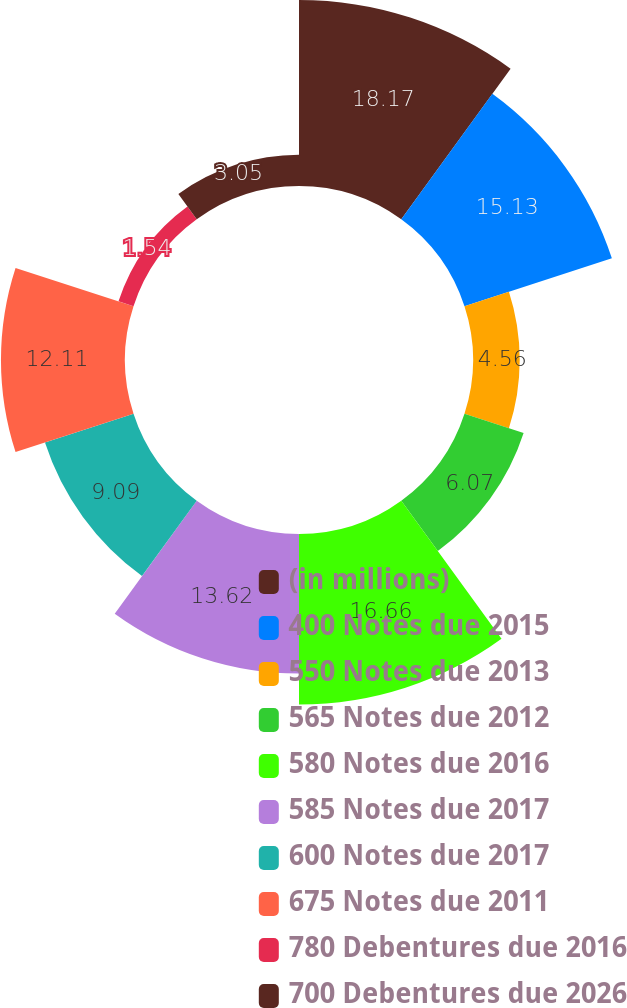Convert chart. <chart><loc_0><loc_0><loc_500><loc_500><pie_chart><fcel>(in millions)<fcel>400 Notes due 2015<fcel>550 Notes due 2013<fcel>565 Notes due 2012<fcel>580 Notes due 2016<fcel>585 Notes due 2017<fcel>600 Notes due 2017<fcel>675 Notes due 2011<fcel>780 Debentures due 2016<fcel>700 Debentures due 2026<nl><fcel>18.16%<fcel>15.13%<fcel>4.56%<fcel>6.07%<fcel>16.65%<fcel>13.62%<fcel>9.09%<fcel>12.11%<fcel>1.54%<fcel>3.05%<nl></chart> 